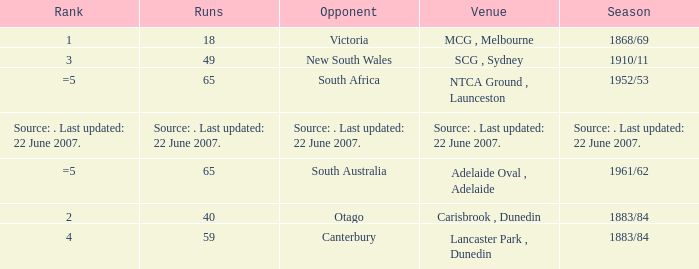Which Run has an Opponent of Canterbury? 59.0. 